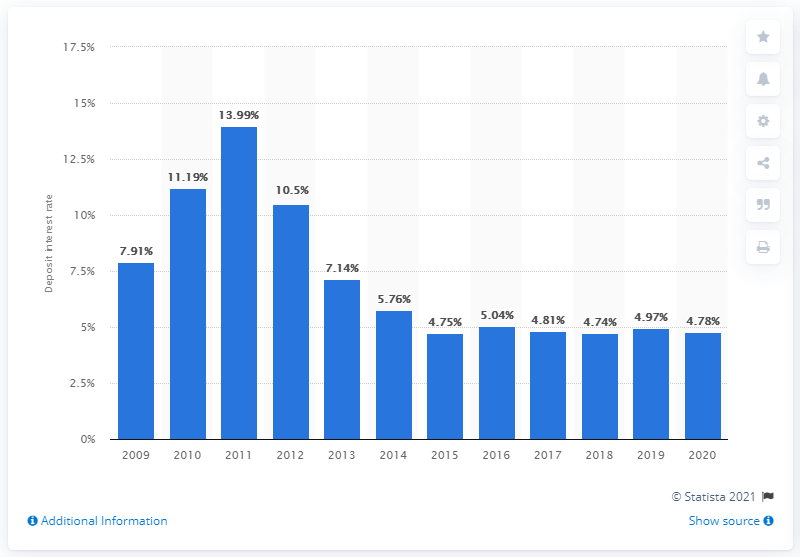Highlight a few significant elements in this photo. In 2011, the highest deposit interest rate in Vietnam was 13.99%. 